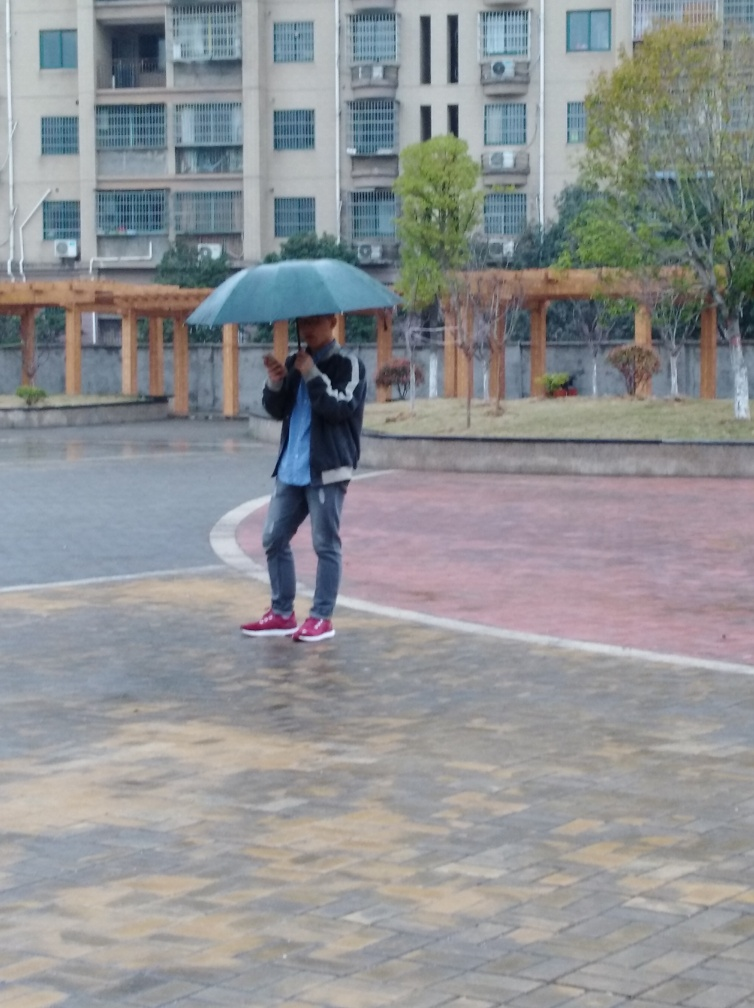What is the weather like in the image? The weather looks overcast with possible rain, as evidenced by the person holding an umbrella and the wet ground surfaces. What could this person be doing? The individual appears to be walking across a paved area while using a mobile device, possibly texting or browsing, which is a common multitasking activity that people do. 